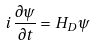Convert formula to latex. <formula><loc_0><loc_0><loc_500><loc_500>i \, \frac { \partial \psi } { \partial t } = H _ { D } \psi</formula> 